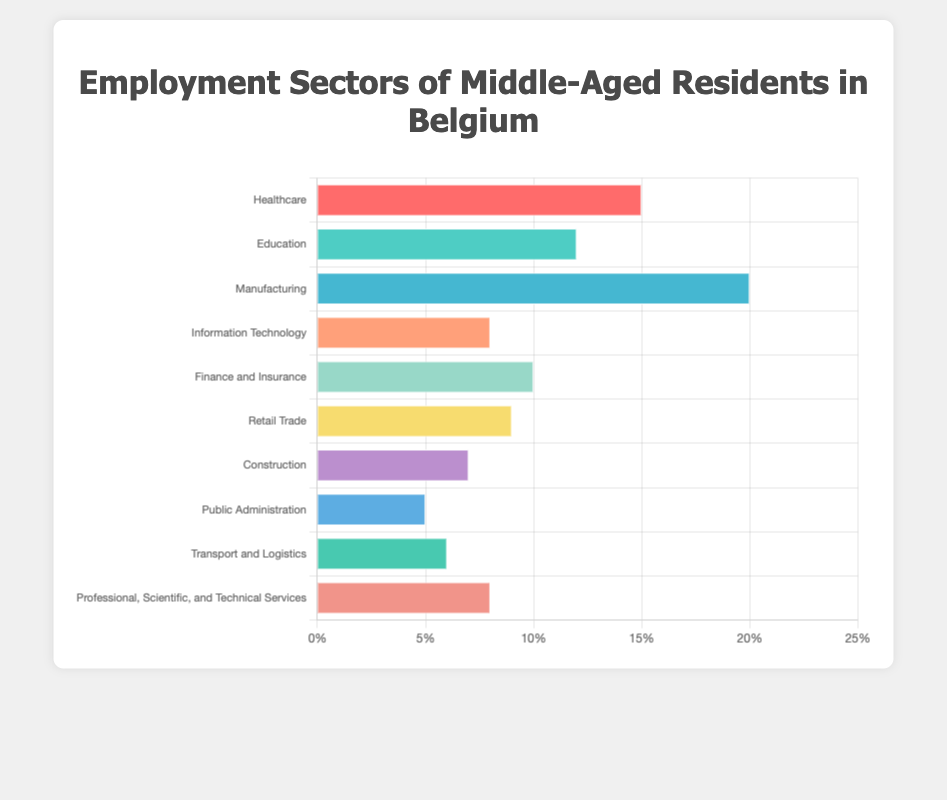What sector employs the highest percentage of middle-aged residents in Belgium? The bar chart shows that Manufacturing has the tallest bar, indicating it employs the highest percentage of middle-aged residents.
Answer: Manufacturing What is the combined percentage of middle-aged workers in the Healthcare and Education sectors? The bar for Healthcare is at 15%, and the bar for Education is at 12%. Adding these together: 15% + 12% = 27%.
Answer: 27% Which sector employs more middle-aged residents: Finance and Insurance or Information Technology? Compare the heights of the bars for Finance and Insurance (10%) and Information Technology (8%). Finance and Insurance employs more at 10%.
Answer: Finance and Insurance What is the difference in employment percentages between Manufacturing and Public Administration? The bar for Manufacturing is at 20%, and the bar for Public Administration is at 5%. Subtract these values: 20% - 5% = 15%.
Answer: 15% Which sector has the smallest percentage of middle-aged employees? The shortest bar corresponds to the sector with the smallest percentage, which is Public Administration at 5%.
Answer: Public Administration How many sectors employ at least 10% of the middle-aged population? Identify the bars that reach the 10% mark or higher: Healthcare (15%), Education (12%), Manufacturing (20%), and Finance and Insurance (10%). There are four sectors.
Answer: 4 What is the average percentage of employment across all sectors? Add each sector's percentage and divide by the number of sectors: (15 + 12 + 20 + 8 + 10 + 9 + 7 + 5 + 6 + 8) / 10 = 10%.
Answer: 10% Which has a higher percentage of middle-aged employees: Retail Trade or Construction? The bar for Retail Trade is at 9%, and the bar for Construction is at 7%. Retail Trade has a higher percentage at 9%.
Answer: Retail Trade How much greater is the percentage of middle-aged employees in Healthcare compared to Transport and Logistics? The bar for Healthcare shows 15%, and the bar for Transport and Logistics shows 6%. Subtract these values: 15% - 6% = 9%.
Answer: 9% What is the ratio of middle-aged employees in Manufacturing to those in Information Technology? Manufacturing has 20%, and Information Technology has 8%. The ratio is 20% to 8%, which simplifies to 5:2.
Answer: 5:2 